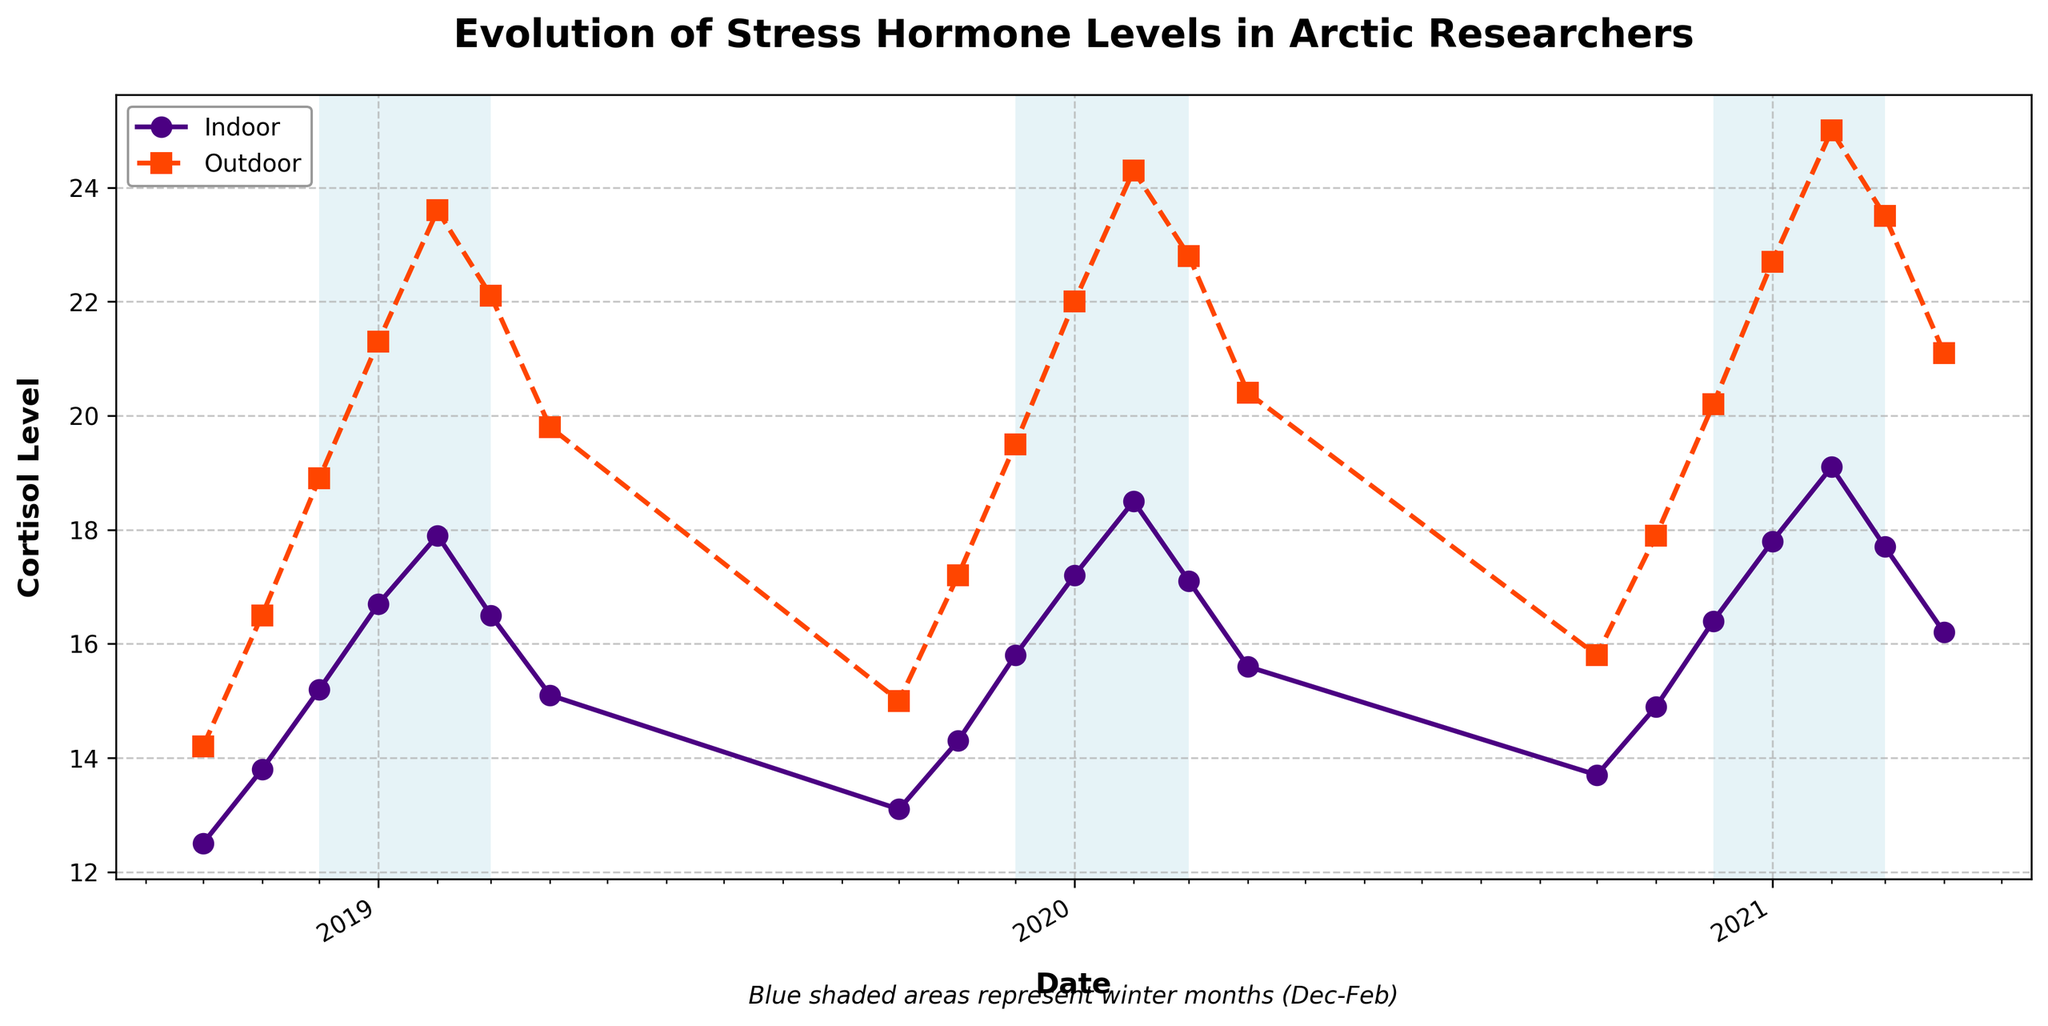What's the highest cortisol level recorded for indoor exposure and in which month and year did it occur? The highest indoor cortisol level can be found by looking at the maximum point on the "Indoor" line. This value is 19.1 observed in February 2021.
Answer: 19.1 in February 2021 How does the outdoor cortisol level in March 2019 compare to March 2020? Look at the values of the "Outdoor" line for March 2019 and March 2020. For March 2019, it's 22.1, and for March 2020, it's 22.8. 22.8 is greater than 22.1.
Answer: March 2020 has higher outdoor cortisol levels (22.8 vs 22.1) What is the average outdoor cortisol level for the winter months (December to February) of 2020? Calculate the average of the outdoor cortisol levels for December 2020, January 2020, and February 2020. The values are 20.2, 22.7, and 25.0, respectively. (20.2 + 22.7 + 25.0) / 3 = 22.63
Answer: 22.63 Is there any month where the indoor cortisol level is greater than the outdoor cortisol level? By examining the lines, it’s evident that for each month, the indoor cortisol level is always less than the outdoor cortisol level according to the figure.
Answer: No What is the difference between the outdoor and indoor cortisol levels in April 2019? Look at the values of the "Indoor" and "Outdoor" lines for April 2019. The values are 15.1 and 19.8, respectively. 19.8 - 15.1 = 4.7
Answer: 4.7 During which period of time do the pink squares appear most frequently at the highest positions on the graph? The pink squares represent outdoor cortisol levels. The trend shows that during January and February, these squares are highest on the graph. This occurs consistently each winter season (January and February of 2019, 2020, and 2021).
Answer: January and February in each year What’s the average cortisol level difference between indoor and outdoor exposure in November across all years? Calculate the differences for November in each year (16.5 - 13.8, 17.2 - 14.3, 17.9 - 14.9), then find the average of these differences: (2.7 + 2.9 + 3.0)/3 = 2.87.
Answer: 2.87 